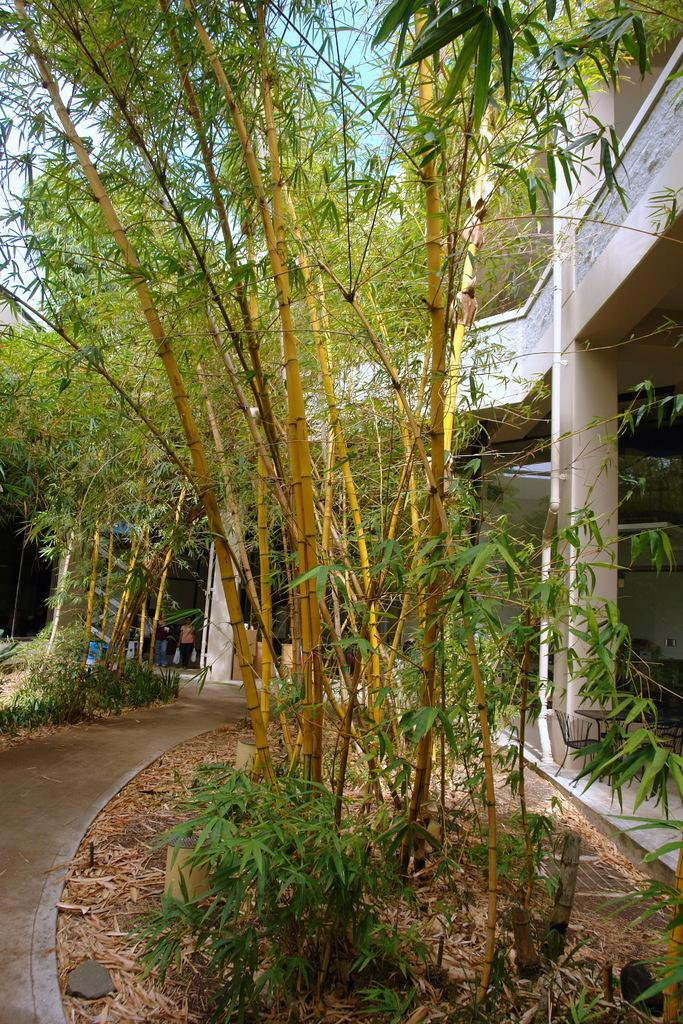What type of trees are in the image? There are bamboo trees in the image. Where are the bamboo trees located in the image? The bamboo trees are in the middle of the image. What else can be seen on the right side of the image? There is a building on the right side of the image. What type of card is being used to measure the stem of the bamboo tree in the image? There is no card or measurement of the bamboo tree's stem present in the image. 